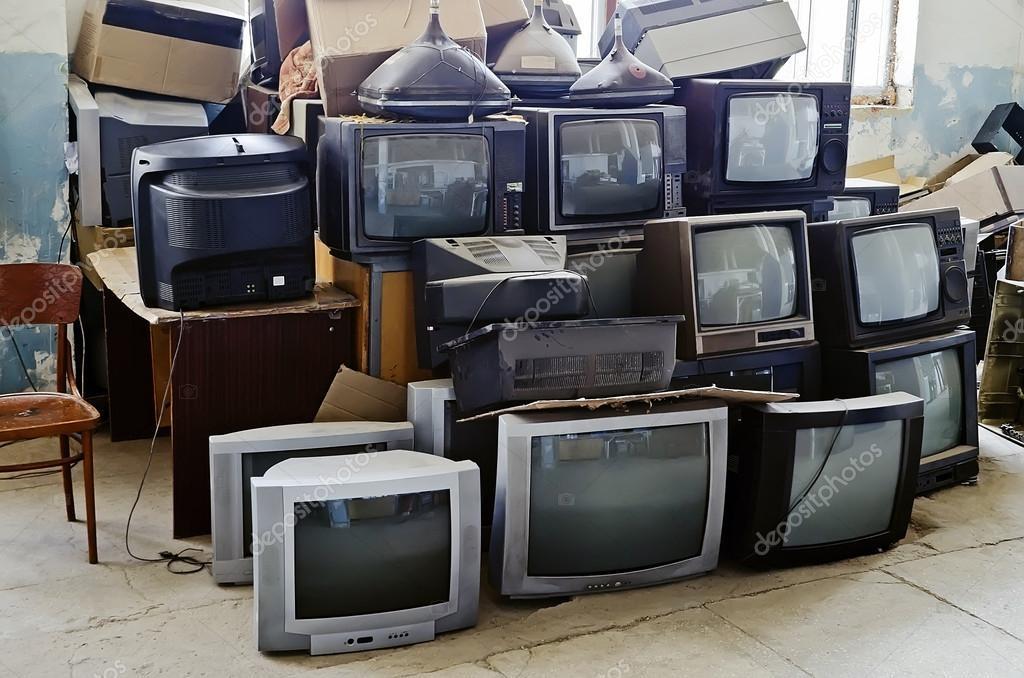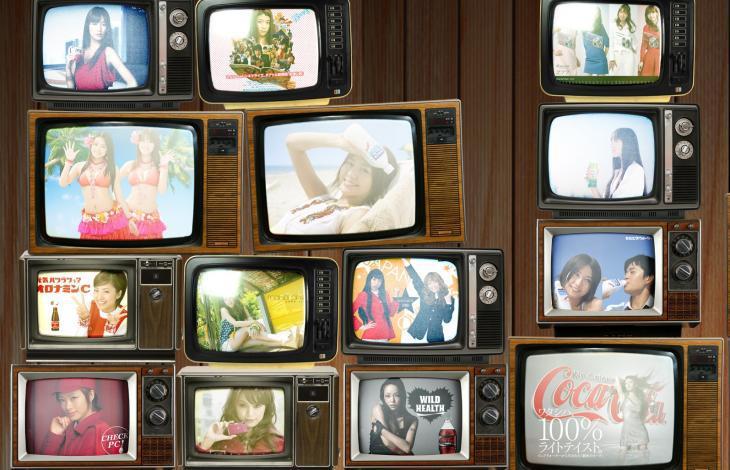The first image is the image on the left, the second image is the image on the right. Given the left and right images, does the statement "The televisions in the image on the right are all turned on." hold true? Answer yes or no. Yes. The first image is the image on the left, the second image is the image on the right. Considering the images on both sides, is "All the TVs stacked in the right image have different scenes playing on the screens." valid? Answer yes or no. Yes. 